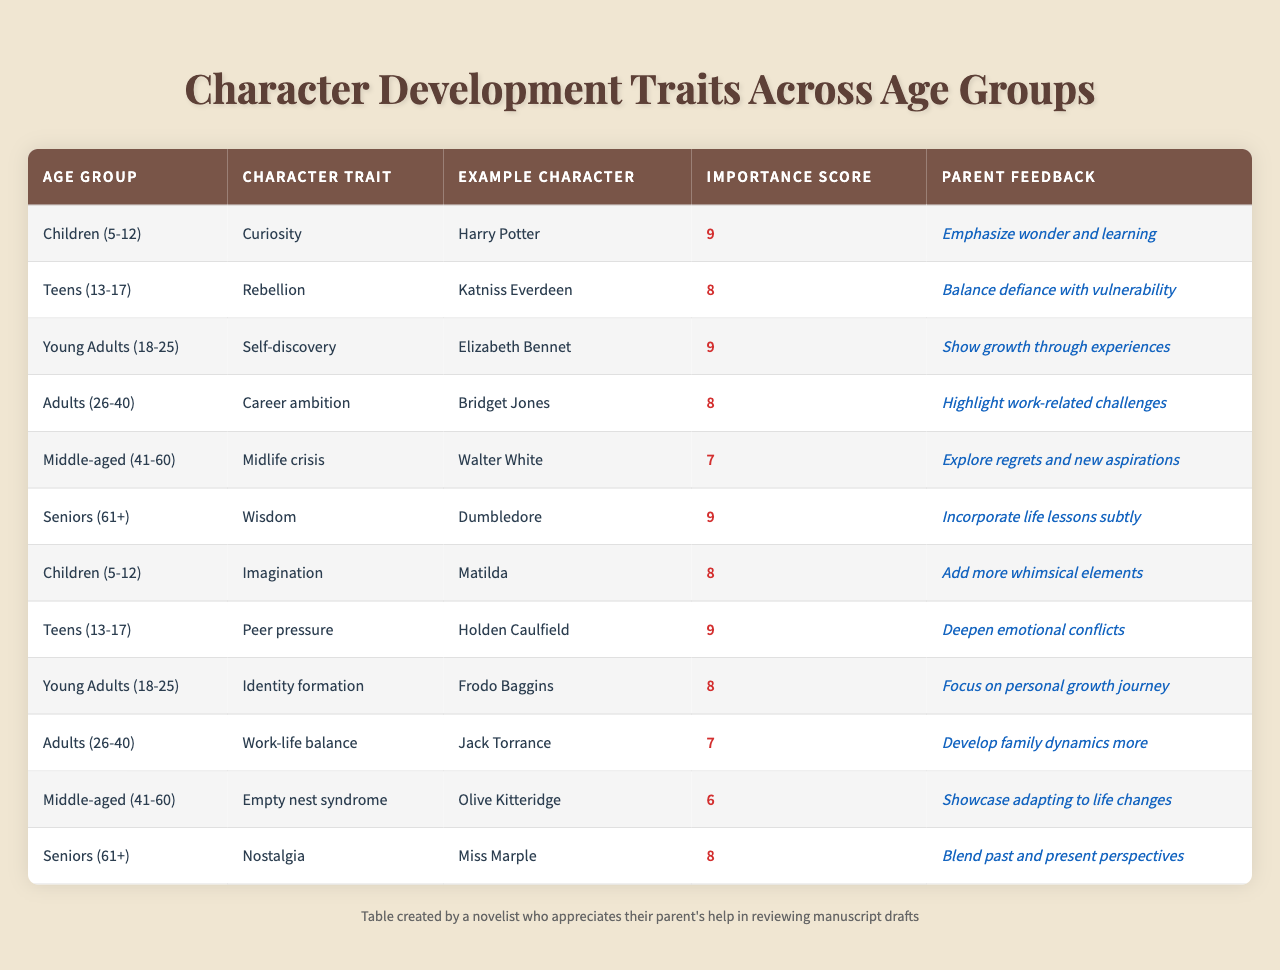What character trait is associated with the age group "Seniors (61+)"? According to the table, the character trait for the age group "Seniors (61+)" is "Wisdom". This is directly listed under the trait column for that age group.
Answer: Wisdom What is the importance score for "Teens (13-17)"? The importance score for the age group "Teens (13-17)" is 9, as indicated in the corresponding row of the table.
Answer: 9 Which example character is associated with the character trait "Self-discovery"? The character trait "Self-discovery" is associated with the example character "Elizabeth Bennet" as per the table's entry for the Young Adults (18-25) group.
Answer: Elizabeth Bennet What is the average importance score for the character traits of "Children (5-12)"? To find the average for "Children (5-12)", we look at the scores: 9 (Curiosity) and 8 (Imagination). The sum is 17, divided by 2 gives an average of 8.5.
Answer: 8.5 Is "Peer pressure" a character trait for any age group in the table? Yes, "Peer pressure" is indeed listed as a character trait for the age group "Teens (13-17)" in the table.
Answer: Yes Which age group has a character trait of "Midlife crisis"? The character trait "Midlife crisis" is associated with the age group "Middle-aged (41-60)", as shown in the table.
Answer: Middle-aged (41-60) What is the difference between the importance scores of "Adults (26-40)" and "Seniors (61+)"? The importance score of "Adults (26-40)" is 8, while for "Seniors (61+)", it is 9. The difference is 9 - 8 = 1.
Answer: 1 What feedback do parents give regarding the character trait of "Nostalgia"? Parents suggest blending past and present perspectives for the character trait "Nostalgia", as stated in the feedback section of the table.
Answer: Blend past and present perspectives Which character is linked to the trait "Career ambition"? The character trait "Career ambition" is linked to the character "Bridget Jones", according to the table's entry for Adults (26-40).
Answer: Bridget Jones List all character traits associated with the age group "Middle-aged (41-60)" and their importance scores. The age group "Middle-aged (41-60)" has two traits listed: "Midlife crisis" with an importance score of 7 and "Empty nest syndrome" with a score of 6. Both traits are found in the respective row of the table.
Answer: Midlife crisis (7), Empty nest syndrome (6) 